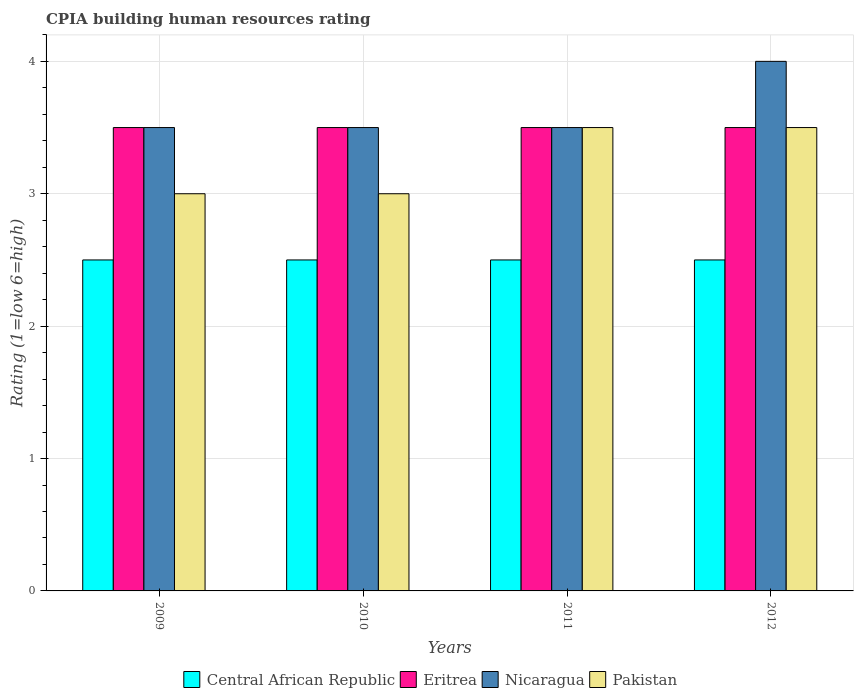How many groups of bars are there?
Provide a short and direct response. 4. Are the number of bars on each tick of the X-axis equal?
Keep it short and to the point. Yes. What is the label of the 2nd group of bars from the left?
Give a very brief answer. 2010. What is the CPIA rating in Central African Republic in 2011?
Offer a terse response. 2.5. Across all years, what is the maximum CPIA rating in Nicaragua?
Your answer should be very brief. 4. Across all years, what is the minimum CPIA rating in Central African Republic?
Provide a short and direct response. 2.5. In which year was the CPIA rating in Eritrea maximum?
Offer a very short reply. 2009. What is the total CPIA rating in Central African Republic in the graph?
Offer a very short reply. 10. What is the average CPIA rating in Nicaragua per year?
Ensure brevity in your answer.  3.62. In the year 2010, what is the difference between the CPIA rating in Eritrea and CPIA rating in Central African Republic?
Provide a short and direct response. 1. Is the difference between the CPIA rating in Eritrea in 2009 and 2010 greater than the difference between the CPIA rating in Central African Republic in 2009 and 2010?
Offer a terse response. No. Is the sum of the CPIA rating in Nicaragua in 2010 and 2012 greater than the maximum CPIA rating in Eritrea across all years?
Offer a terse response. Yes. What does the 3rd bar from the left in 2011 represents?
Make the answer very short. Nicaragua. What does the 2nd bar from the right in 2009 represents?
Provide a succinct answer. Nicaragua. Is it the case that in every year, the sum of the CPIA rating in Pakistan and CPIA rating in Central African Republic is greater than the CPIA rating in Eritrea?
Offer a terse response. Yes. How many bars are there?
Offer a very short reply. 16. How many years are there in the graph?
Keep it short and to the point. 4. Are the values on the major ticks of Y-axis written in scientific E-notation?
Ensure brevity in your answer.  No. Does the graph contain any zero values?
Provide a short and direct response. No. How many legend labels are there?
Your answer should be compact. 4. How are the legend labels stacked?
Give a very brief answer. Horizontal. What is the title of the graph?
Offer a terse response. CPIA building human resources rating. What is the Rating (1=low 6=high) of Central African Republic in 2009?
Your answer should be compact. 2.5. What is the Rating (1=low 6=high) of Eritrea in 2009?
Provide a succinct answer. 3.5. What is the Rating (1=low 6=high) of Nicaragua in 2009?
Keep it short and to the point. 3.5. What is the Rating (1=low 6=high) of Pakistan in 2009?
Provide a short and direct response. 3. What is the Rating (1=low 6=high) of Nicaragua in 2010?
Your answer should be very brief. 3.5. What is the Rating (1=low 6=high) of Central African Republic in 2012?
Make the answer very short. 2.5. What is the Rating (1=low 6=high) of Nicaragua in 2012?
Your answer should be compact. 4. Across all years, what is the maximum Rating (1=low 6=high) of Central African Republic?
Your response must be concise. 2.5. Across all years, what is the maximum Rating (1=low 6=high) in Eritrea?
Keep it short and to the point. 3.5. Across all years, what is the maximum Rating (1=low 6=high) in Nicaragua?
Your answer should be very brief. 4. Across all years, what is the maximum Rating (1=low 6=high) in Pakistan?
Your answer should be very brief. 3.5. Across all years, what is the minimum Rating (1=low 6=high) in Central African Republic?
Offer a very short reply. 2.5. Across all years, what is the minimum Rating (1=low 6=high) of Eritrea?
Keep it short and to the point. 3.5. What is the total Rating (1=low 6=high) of Central African Republic in the graph?
Your response must be concise. 10. What is the total Rating (1=low 6=high) in Eritrea in the graph?
Make the answer very short. 14. What is the total Rating (1=low 6=high) of Pakistan in the graph?
Ensure brevity in your answer.  13. What is the difference between the Rating (1=low 6=high) in Central African Republic in 2009 and that in 2010?
Give a very brief answer. 0. What is the difference between the Rating (1=low 6=high) of Eritrea in 2009 and that in 2010?
Offer a very short reply. 0. What is the difference between the Rating (1=low 6=high) of Pakistan in 2009 and that in 2010?
Ensure brevity in your answer.  0. What is the difference between the Rating (1=low 6=high) of Central African Republic in 2009 and that in 2011?
Provide a short and direct response. 0. What is the difference between the Rating (1=low 6=high) of Eritrea in 2009 and that in 2011?
Provide a short and direct response. 0. What is the difference between the Rating (1=low 6=high) in Central African Republic in 2009 and that in 2012?
Your answer should be very brief. 0. What is the difference between the Rating (1=low 6=high) of Eritrea in 2009 and that in 2012?
Your answer should be compact. 0. What is the difference between the Rating (1=low 6=high) in Nicaragua in 2009 and that in 2012?
Make the answer very short. -0.5. What is the difference between the Rating (1=low 6=high) of Pakistan in 2009 and that in 2012?
Provide a succinct answer. -0.5. What is the difference between the Rating (1=low 6=high) of Central African Republic in 2010 and that in 2011?
Your answer should be very brief. 0. What is the difference between the Rating (1=low 6=high) in Eritrea in 2010 and that in 2011?
Your answer should be compact. 0. What is the difference between the Rating (1=low 6=high) of Nicaragua in 2010 and that in 2011?
Offer a very short reply. 0. What is the difference between the Rating (1=low 6=high) in Pakistan in 2010 and that in 2012?
Your answer should be very brief. -0.5. What is the difference between the Rating (1=low 6=high) in Central African Republic in 2011 and that in 2012?
Ensure brevity in your answer.  0. What is the difference between the Rating (1=low 6=high) of Eritrea in 2011 and that in 2012?
Make the answer very short. 0. What is the difference between the Rating (1=low 6=high) in Nicaragua in 2011 and that in 2012?
Give a very brief answer. -0.5. What is the difference between the Rating (1=low 6=high) in Central African Republic in 2009 and the Rating (1=low 6=high) in Eritrea in 2010?
Provide a short and direct response. -1. What is the difference between the Rating (1=low 6=high) of Eritrea in 2009 and the Rating (1=low 6=high) of Pakistan in 2010?
Offer a terse response. 0.5. What is the difference between the Rating (1=low 6=high) in Central African Republic in 2009 and the Rating (1=low 6=high) in Nicaragua in 2011?
Offer a very short reply. -1. What is the difference between the Rating (1=low 6=high) in Eritrea in 2009 and the Rating (1=low 6=high) in Pakistan in 2011?
Provide a succinct answer. 0. What is the difference between the Rating (1=low 6=high) of Eritrea in 2009 and the Rating (1=low 6=high) of Nicaragua in 2012?
Your answer should be compact. -0.5. What is the difference between the Rating (1=low 6=high) in Eritrea in 2009 and the Rating (1=low 6=high) in Pakistan in 2012?
Your answer should be compact. 0. What is the difference between the Rating (1=low 6=high) in Central African Republic in 2010 and the Rating (1=low 6=high) in Nicaragua in 2011?
Your answer should be very brief. -1. What is the difference between the Rating (1=low 6=high) in Central African Republic in 2010 and the Rating (1=low 6=high) in Pakistan in 2011?
Offer a very short reply. -1. What is the difference between the Rating (1=low 6=high) in Eritrea in 2010 and the Rating (1=low 6=high) in Pakistan in 2011?
Your answer should be compact. 0. What is the difference between the Rating (1=low 6=high) in Nicaragua in 2010 and the Rating (1=low 6=high) in Pakistan in 2011?
Offer a very short reply. 0. What is the difference between the Rating (1=low 6=high) of Central African Republic in 2010 and the Rating (1=low 6=high) of Nicaragua in 2012?
Keep it short and to the point. -1.5. What is the difference between the Rating (1=low 6=high) in Central African Republic in 2011 and the Rating (1=low 6=high) in Nicaragua in 2012?
Provide a short and direct response. -1.5. What is the difference between the Rating (1=low 6=high) in Central African Republic in 2011 and the Rating (1=low 6=high) in Pakistan in 2012?
Make the answer very short. -1. What is the difference between the Rating (1=low 6=high) in Nicaragua in 2011 and the Rating (1=low 6=high) in Pakistan in 2012?
Your response must be concise. 0. What is the average Rating (1=low 6=high) of Central African Republic per year?
Give a very brief answer. 2.5. What is the average Rating (1=low 6=high) in Nicaragua per year?
Provide a succinct answer. 3.62. In the year 2009, what is the difference between the Rating (1=low 6=high) of Central African Republic and Rating (1=low 6=high) of Eritrea?
Keep it short and to the point. -1. In the year 2009, what is the difference between the Rating (1=low 6=high) of Nicaragua and Rating (1=low 6=high) of Pakistan?
Offer a terse response. 0.5. In the year 2010, what is the difference between the Rating (1=low 6=high) in Central African Republic and Rating (1=low 6=high) in Eritrea?
Offer a very short reply. -1. In the year 2010, what is the difference between the Rating (1=low 6=high) of Central African Republic and Rating (1=low 6=high) of Nicaragua?
Keep it short and to the point. -1. In the year 2010, what is the difference between the Rating (1=low 6=high) in Central African Republic and Rating (1=low 6=high) in Pakistan?
Provide a short and direct response. -0.5. In the year 2011, what is the difference between the Rating (1=low 6=high) in Central African Republic and Rating (1=low 6=high) in Eritrea?
Your response must be concise. -1. In the year 2011, what is the difference between the Rating (1=low 6=high) in Central African Republic and Rating (1=low 6=high) in Nicaragua?
Offer a terse response. -1. In the year 2011, what is the difference between the Rating (1=low 6=high) in Central African Republic and Rating (1=low 6=high) in Pakistan?
Make the answer very short. -1. In the year 2012, what is the difference between the Rating (1=low 6=high) of Central African Republic and Rating (1=low 6=high) of Eritrea?
Make the answer very short. -1. In the year 2012, what is the difference between the Rating (1=low 6=high) in Eritrea and Rating (1=low 6=high) in Nicaragua?
Provide a short and direct response. -0.5. What is the ratio of the Rating (1=low 6=high) in Nicaragua in 2009 to that in 2010?
Ensure brevity in your answer.  1. What is the ratio of the Rating (1=low 6=high) in Central African Republic in 2009 to that in 2011?
Ensure brevity in your answer.  1. What is the ratio of the Rating (1=low 6=high) of Eritrea in 2009 to that in 2011?
Make the answer very short. 1. What is the ratio of the Rating (1=low 6=high) of Pakistan in 2009 to that in 2011?
Offer a terse response. 0.86. What is the ratio of the Rating (1=low 6=high) of Eritrea in 2009 to that in 2012?
Your answer should be compact. 1. What is the ratio of the Rating (1=low 6=high) in Central African Republic in 2010 to that in 2011?
Your answer should be very brief. 1. What is the ratio of the Rating (1=low 6=high) of Nicaragua in 2010 to that in 2011?
Offer a very short reply. 1. What is the ratio of the Rating (1=low 6=high) of Eritrea in 2010 to that in 2012?
Offer a terse response. 1. What is the ratio of the Rating (1=low 6=high) in Central African Republic in 2011 to that in 2012?
Your response must be concise. 1. What is the ratio of the Rating (1=low 6=high) in Eritrea in 2011 to that in 2012?
Offer a terse response. 1. What is the ratio of the Rating (1=low 6=high) in Nicaragua in 2011 to that in 2012?
Offer a very short reply. 0.88. What is the ratio of the Rating (1=low 6=high) of Pakistan in 2011 to that in 2012?
Give a very brief answer. 1. What is the difference between the highest and the second highest Rating (1=low 6=high) of Central African Republic?
Your response must be concise. 0. What is the difference between the highest and the second highest Rating (1=low 6=high) in Nicaragua?
Provide a short and direct response. 0.5. What is the difference between the highest and the second highest Rating (1=low 6=high) of Pakistan?
Your response must be concise. 0. What is the difference between the highest and the lowest Rating (1=low 6=high) of Central African Republic?
Offer a terse response. 0. What is the difference between the highest and the lowest Rating (1=low 6=high) of Nicaragua?
Offer a terse response. 0.5. What is the difference between the highest and the lowest Rating (1=low 6=high) in Pakistan?
Ensure brevity in your answer.  0.5. 